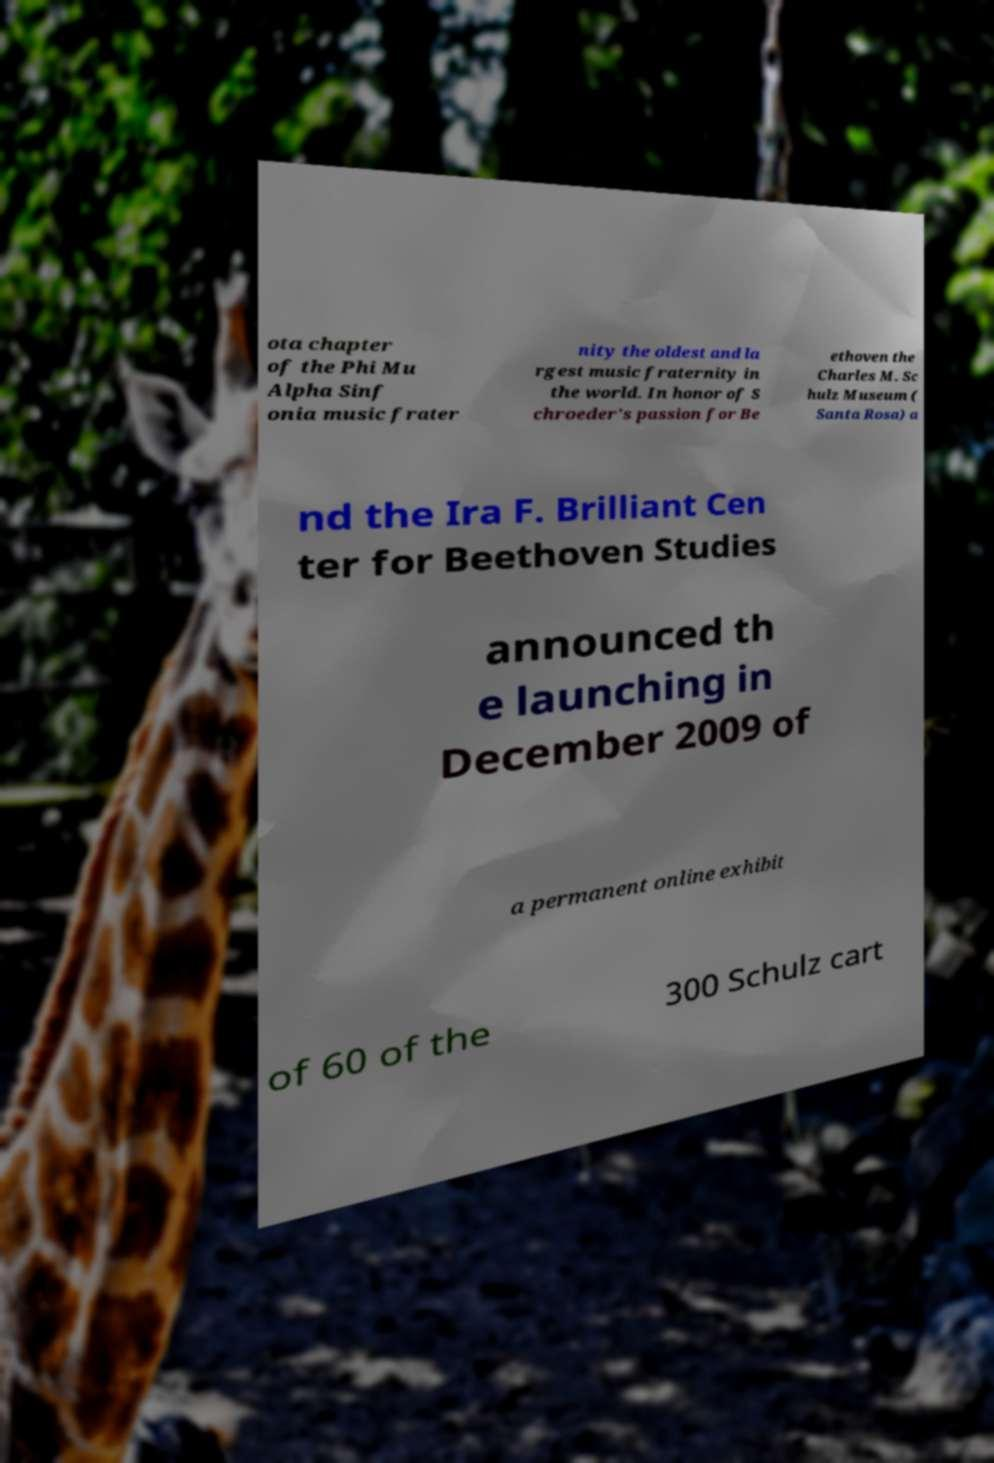I need the written content from this picture converted into text. Can you do that? ota chapter of the Phi Mu Alpha Sinf onia music frater nity the oldest and la rgest music fraternity in the world. In honor of S chroeder's passion for Be ethoven the Charles M. Sc hulz Museum ( Santa Rosa) a nd the Ira F. Brilliant Cen ter for Beethoven Studies announced th e launching in December 2009 of a permanent online exhibit of 60 of the 300 Schulz cart 